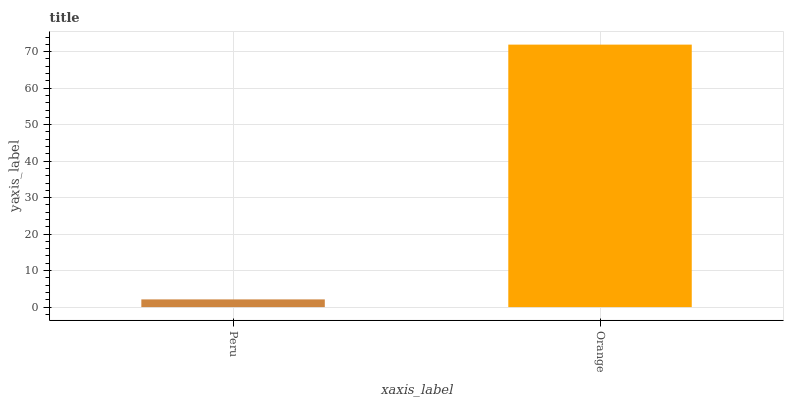Is Orange the minimum?
Answer yes or no. No. Is Orange greater than Peru?
Answer yes or no. Yes. Is Peru less than Orange?
Answer yes or no. Yes. Is Peru greater than Orange?
Answer yes or no. No. Is Orange less than Peru?
Answer yes or no. No. Is Orange the high median?
Answer yes or no. Yes. Is Peru the low median?
Answer yes or no. Yes. Is Peru the high median?
Answer yes or no. No. Is Orange the low median?
Answer yes or no. No. 